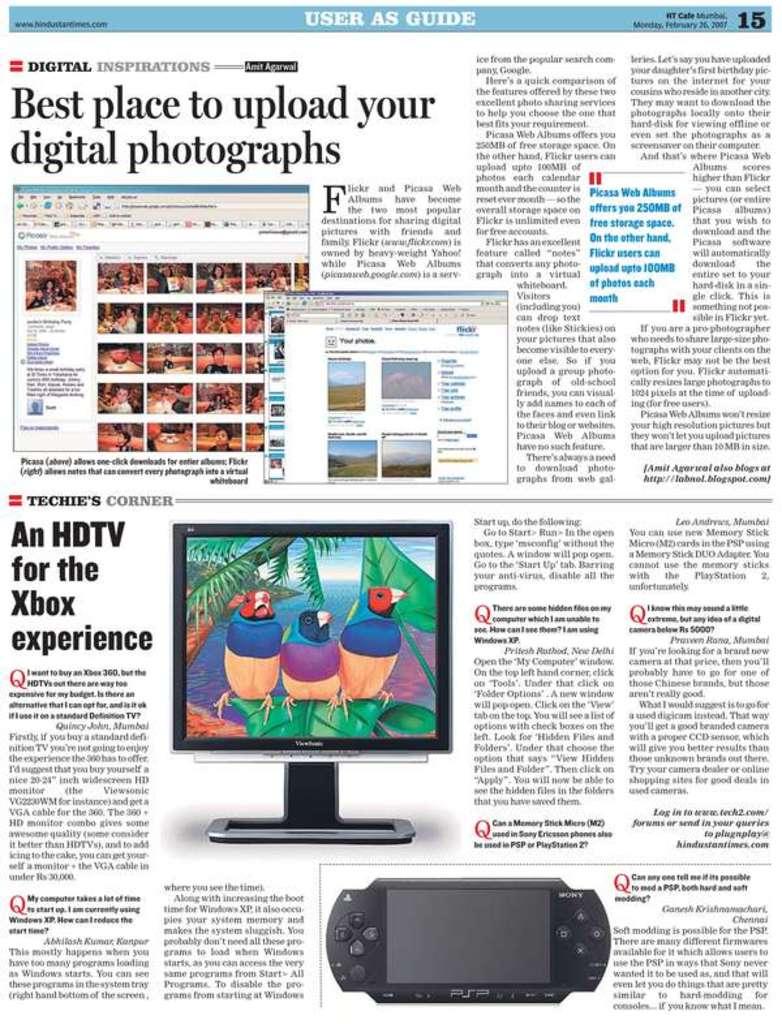What is the article informing the reader on?
Your answer should be compact. Best place to upload your digital photographs. 